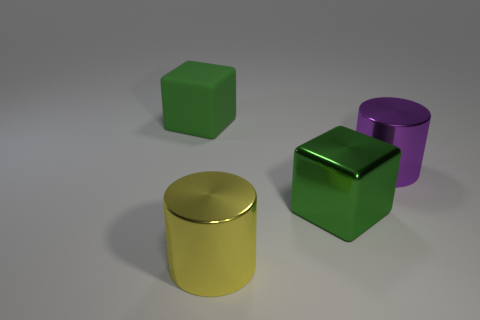What number of other objects are there of the same color as the rubber cube?
Provide a short and direct response. 1. What is the color of the shiny cylinder that is on the right side of the cylinder that is in front of the purple cylinder?
Your answer should be compact. Purple. There is a matte object; is its shape the same as the green object that is in front of the big purple thing?
Offer a terse response. Yes. What number of green shiny blocks have the same size as the green rubber thing?
Give a very brief answer. 1. What material is the other green object that is the same shape as the large green metal object?
Keep it short and to the point. Rubber. There is a large thing on the left side of the yellow metal cylinder; is it the same color as the large cube to the right of the yellow metallic object?
Your response must be concise. Yes. The purple metallic thing in front of the big green matte thing has what shape?
Provide a short and direct response. Cylinder. The large shiny cube is what color?
Make the answer very short. Green. The large green thing that is made of the same material as the big purple cylinder is what shape?
Provide a short and direct response. Cube. Is the size of the metallic cylinder behind the yellow metal cylinder the same as the large yellow metallic thing?
Your answer should be compact. Yes. 